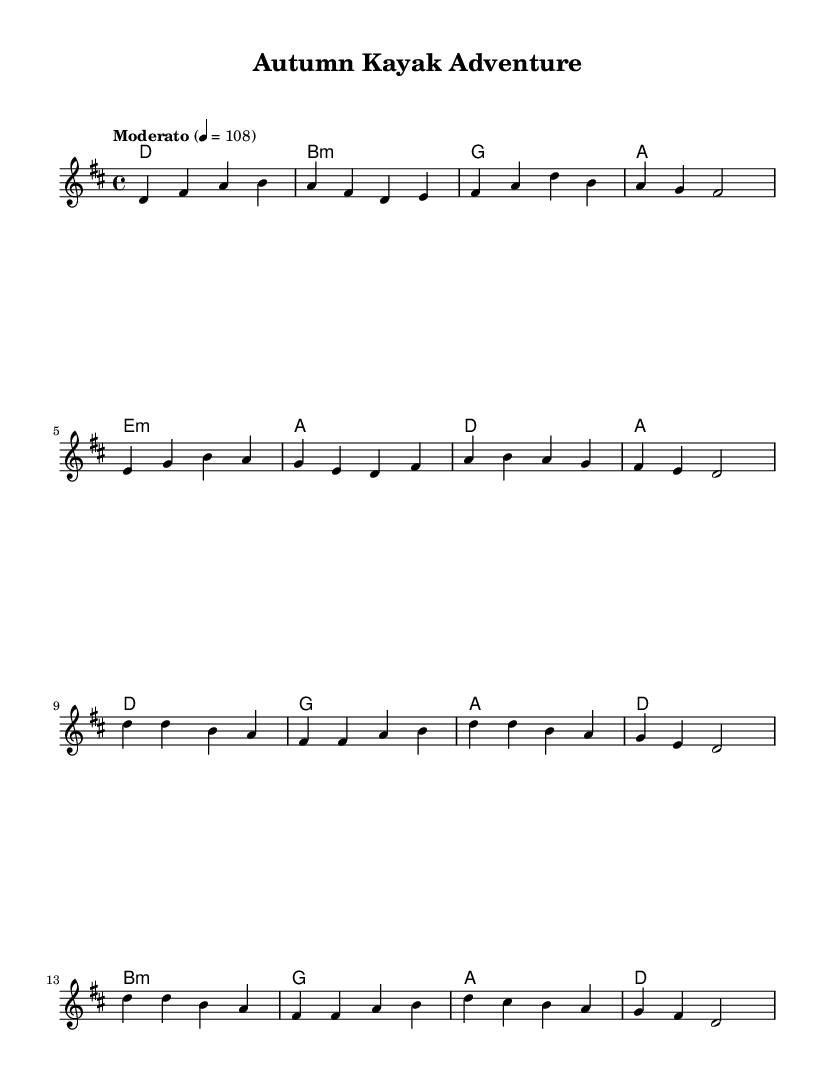What is the key signature of this music? The key signature is D major, indicated by the presence of two sharps, F# and C#.
Answer: D major What is the time signature of this music? The time signature is 4/4, meaning there are four beats in a measure, and the quarter note gets one beat.
Answer: 4/4 What is the tempo marking for this piece? The tempo marking indicates Moderato, which suggests a moderate speed of 108 beats per minute.
Answer: Moderato How many measures are there in the verse section? The verse section consists of eight measures; by counting the vertical lines (bar lines), we observe eight groupings.
Answer: Eight Which chord follows the A chord in the verse? The chord that follows the A chord in the verse is the E minor chord, as indicated in the sequence of chords.
Answer: E minor What is the first note of the chorus section? The first note of the chorus section is D, as noted at the beginning of the melody for the chorus.
Answer: D How many times does the note D appear in the first chorus? The note D appears six times in the first chorus, which can be counted directly from the melody line in the score.
Answer: Six 